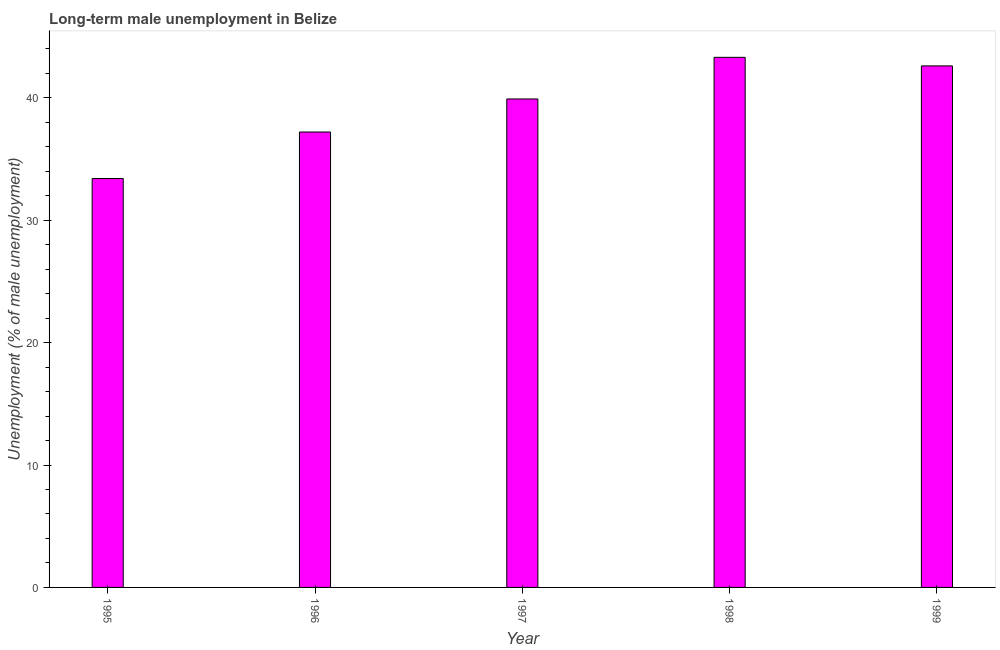Does the graph contain any zero values?
Keep it short and to the point. No. Does the graph contain grids?
Keep it short and to the point. No. What is the title of the graph?
Provide a succinct answer. Long-term male unemployment in Belize. What is the label or title of the Y-axis?
Give a very brief answer. Unemployment (% of male unemployment). What is the long-term male unemployment in 1995?
Give a very brief answer. 33.4. Across all years, what is the maximum long-term male unemployment?
Ensure brevity in your answer.  43.3. Across all years, what is the minimum long-term male unemployment?
Offer a terse response. 33.4. What is the sum of the long-term male unemployment?
Offer a very short reply. 196.4. What is the average long-term male unemployment per year?
Your answer should be compact. 39.28. What is the median long-term male unemployment?
Provide a succinct answer. 39.9. What is the ratio of the long-term male unemployment in 1995 to that in 1998?
Make the answer very short. 0.77. What is the difference between the highest and the second highest long-term male unemployment?
Provide a short and direct response. 0.7. Is the sum of the long-term male unemployment in 1996 and 1999 greater than the maximum long-term male unemployment across all years?
Ensure brevity in your answer.  Yes. What is the difference between the highest and the lowest long-term male unemployment?
Provide a succinct answer. 9.9. How many bars are there?
Your response must be concise. 5. Are all the bars in the graph horizontal?
Keep it short and to the point. No. How many years are there in the graph?
Offer a terse response. 5. Are the values on the major ticks of Y-axis written in scientific E-notation?
Your response must be concise. No. What is the Unemployment (% of male unemployment) in 1995?
Offer a very short reply. 33.4. What is the Unemployment (% of male unemployment) of 1996?
Provide a succinct answer. 37.2. What is the Unemployment (% of male unemployment) of 1997?
Offer a very short reply. 39.9. What is the Unemployment (% of male unemployment) of 1998?
Offer a very short reply. 43.3. What is the Unemployment (% of male unemployment) in 1999?
Offer a very short reply. 42.6. What is the difference between the Unemployment (% of male unemployment) in 1995 and 1996?
Give a very brief answer. -3.8. What is the difference between the Unemployment (% of male unemployment) in 1995 and 1998?
Keep it short and to the point. -9.9. What is the difference between the Unemployment (% of male unemployment) in 1996 and 1997?
Offer a terse response. -2.7. What is the difference between the Unemployment (% of male unemployment) in 1996 and 1998?
Offer a very short reply. -6.1. What is the difference between the Unemployment (% of male unemployment) in 1997 and 1999?
Your response must be concise. -2.7. What is the ratio of the Unemployment (% of male unemployment) in 1995 to that in 1996?
Make the answer very short. 0.9. What is the ratio of the Unemployment (% of male unemployment) in 1995 to that in 1997?
Provide a succinct answer. 0.84. What is the ratio of the Unemployment (% of male unemployment) in 1995 to that in 1998?
Provide a succinct answer. 0.77. What is the ratio of the Unemployment (% of male unemployment) in 1995 to that in 1999?
Provide a short and direct response. 0.78. What is the ratio of the Unemployment (% of male unemployment) in 1996 to that in 1997?
Offer a very short reply. 0.93. What is the ratio of the Unemployment (% of male unemployment) in 1996 to that in 1998?
Keep it short and to the point. 0.86. What is the ratio of the Unemployment (% of male unemployment) in 1996 to that in 1999?
Offer a very short reply. 0.87. What is the ratio of the Unemployment (% of male unemployment) in 1997 to that in 1998?
Ensure brevity in your answer.  0.92. What is the ratio of the Unemployment (% of male unemployment) in 1997 to that in 1999?
Ensure brevity in your answer.  0.94. What is the ratio of the Unemployment (% of male unemployment) in 1998 to that in 1999?
Offer a terse response. 1.02. 